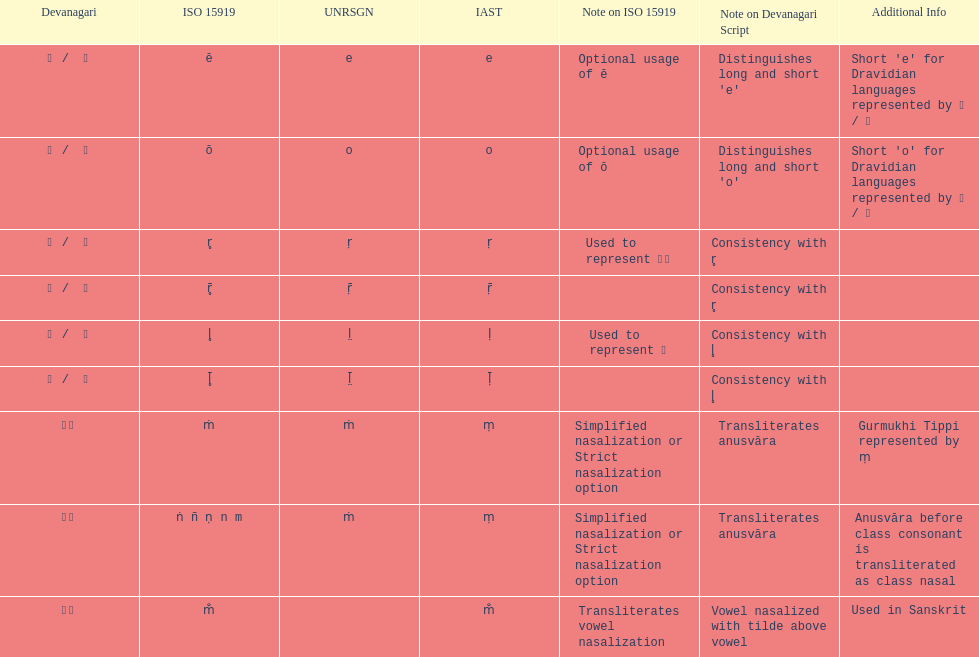What is listed previous to in iso 15919, &#7735; is used to represent &#2355;. under comments? For consistency with r̥. 